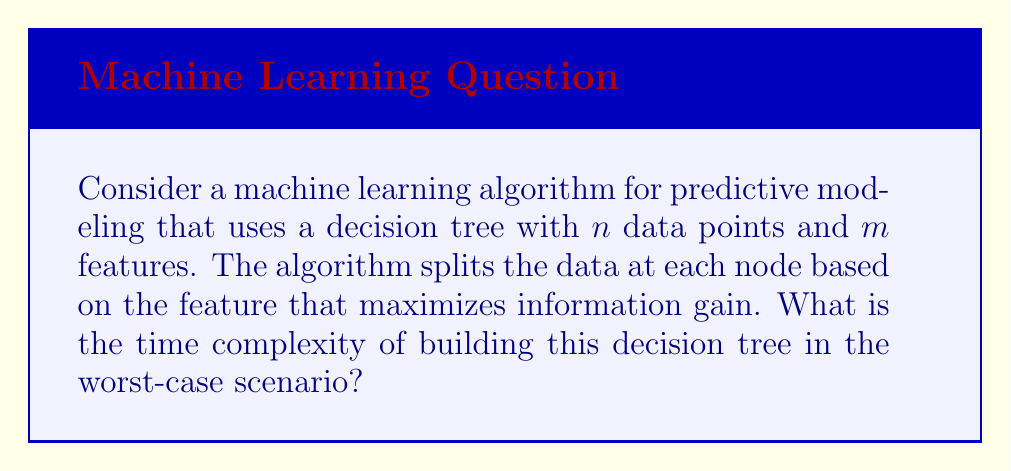What is the answer to this math problem? To analyze the time complexity of building a decision tree, we need to consider the operations performed at each step:

1. For each node:
   a. We need to evaluate all $m$ features
   b. For each feature, we need to sort the data points, which takes $O(n \log n)$ time
   c. After sorting, we calculate the information gain, which takes $O(n)$ time

2. In the worst case, the tree can have a depth of $n$ (when each data point ends up in its own leaf)

Therefore, at each level of the tree, we perform:

$$ O(m \cdot n \log n) $$

operations for sorting and evaluating all features.

The total number of operations across all levels is:

$$ O(m \cdot n^2 \log n) $$

This is because we have $n$ levels in the worst case, and at each level, we're performing $O(m \cdot n \log n)$ operations.

For a data analyst who prefers a sedentary lifestyle, we can think of this as analyzing data points (n) while sitting at a desk, considering various features (m) without the need for physical activity. The process becomes more time-consuming as the dataset grows, similar to how a sedentary person might find it increasingly difficult to process large amounts of information without taking breaks.
Answer: The worst-case time complexity of building the decision tree is $O(m \cdot n^2 \log n)$, where $n$ is the number of data points and $m$ is the number of features. 